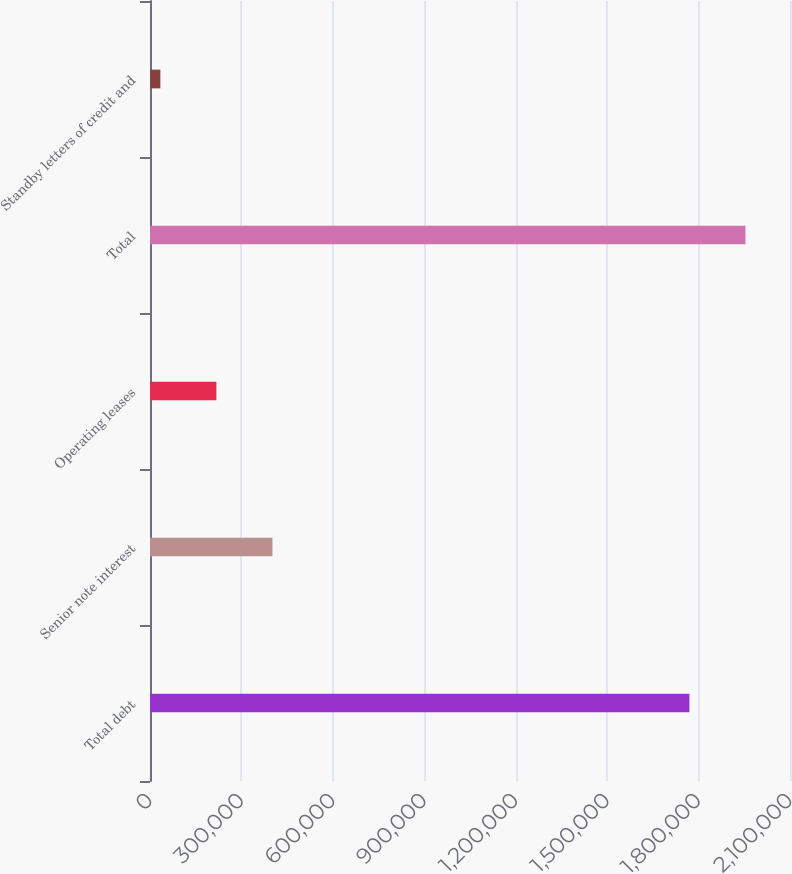Convert chart. <chart><loc_0><loc_0><loc_500><loc_500><bar_chart><fcel>Total debt<fcel>Senior note interest<fcel>Operating leases<fcel>Total<fcel>Standby letters of credit and<nl><fcel>1.77e+06<fcel>401763<fcel>217884<fcel>1.95388e+06<fcel>34006<nl></chart> 